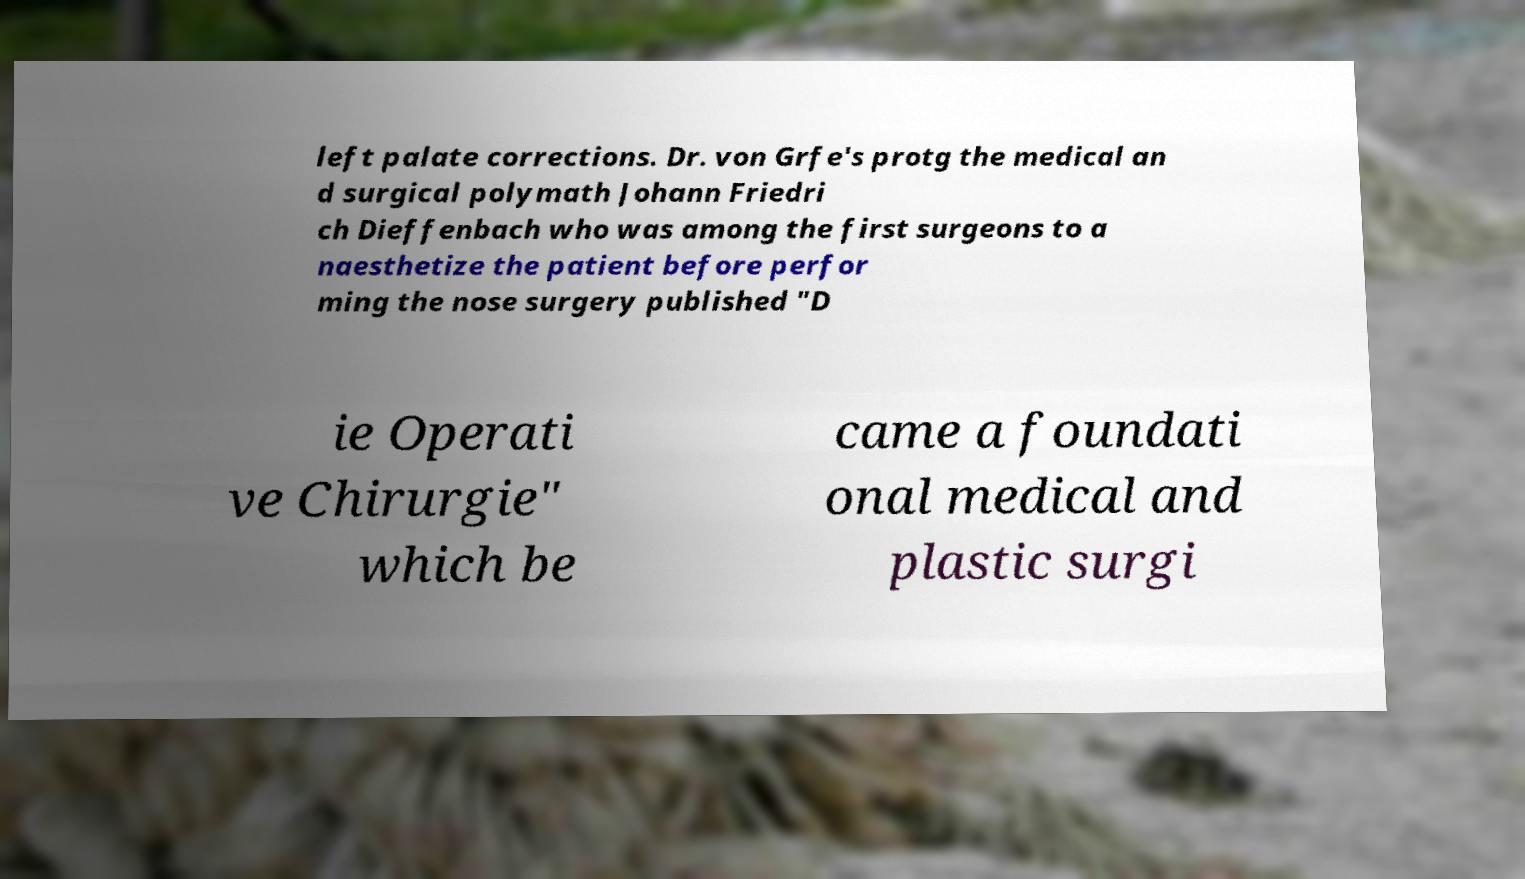Could you assist in decoding the text presented in this image and type it out clearly? left palate corrections. Dr. von Grfe's protg the medical an d surgical polymath Johann Friedri ch Dieffenbach who was among the first surgeons to a naesthetize the patient before perfor ming the nose surgery published "D ie Operati ve Chirurgie" which be came a foundati onal medical and plastic surgi 